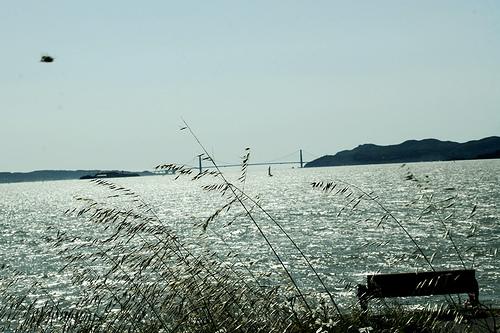What is covering the ground?
Quick response, please. Water. How many people are on the bench?
Answer briefly. 0. Is this an old photo?
Write a very short answer. No. What year was this photo taken?
Quick response, please. 2016. Is there a bench to sit on?
Give a very brief answer. Yes. How many park benches have been flooded?
Quick response, please. 1. Are there clouds in the sky?
Quick response, please. No. Is the water clean?
Write a very short answer. Yes. How many chairs are there?
Short answer required. 1. Is this a color photograph?
Give a very brief answer. Yes. Is someone on the bench?
Give a very brief answer. No. What material is the bench made of?
Concise answer only. Wood. Is it snowing?
Short answer required. No. Has it been snowing?
Short answer required. No. Does it look like it's getting dark in this picture?
Write a very short answer. No. Does the boat have a line attached?
Give a very brief answer. No. Where is a bridge?
Be succinct. Background. Are there people in the photo?
Give a very brief answer. No. 